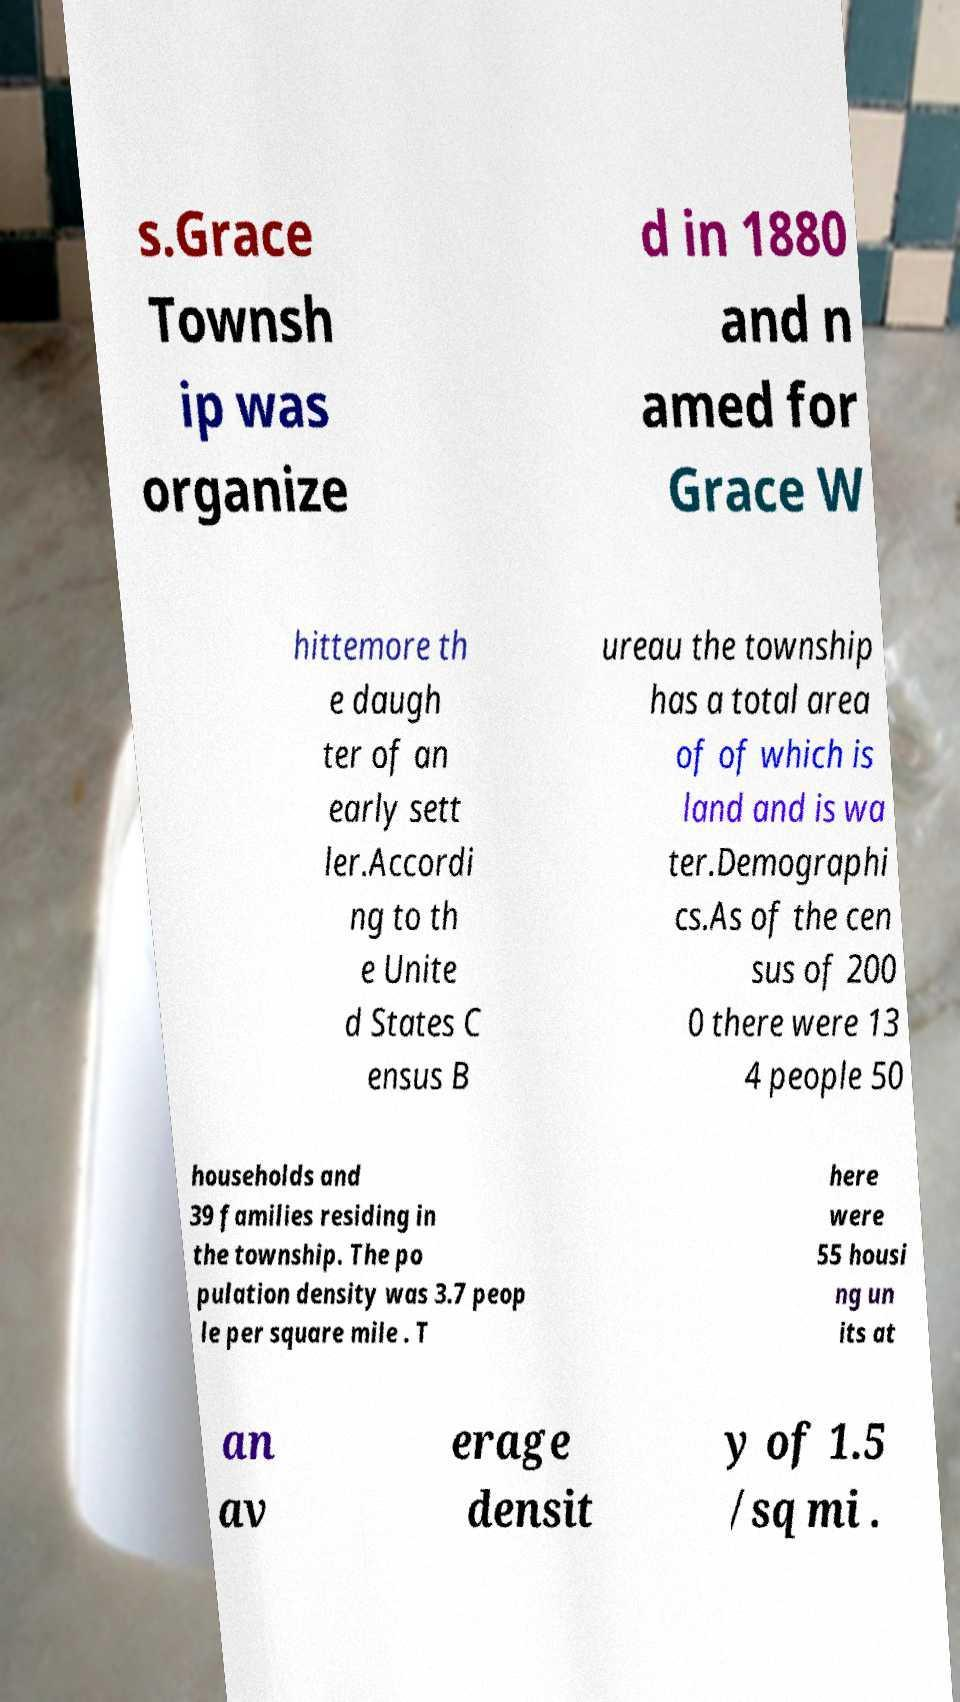For documentation purposes, I need the text within this image transcribed. Could you provide that? s.Grace Townsh ip was organize d in 1880 and n amed for Grace W hittemore th e daugh ter of an early sett ler.Accordi ng to th e Unite d States C ensus B ureau the township has a total area of of which is land and is wa ter.Demographi cs.As of the cen sus of 200 0 there were 13 4 people 50 households and 39 families residing in the township. The po pulation density was 3.7 peop le per square mile . T here were 55 housi ng un its at an av erage densit y of 1.5 /sq mi . 